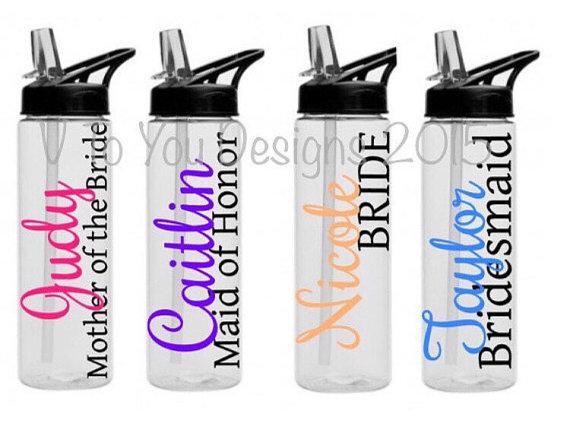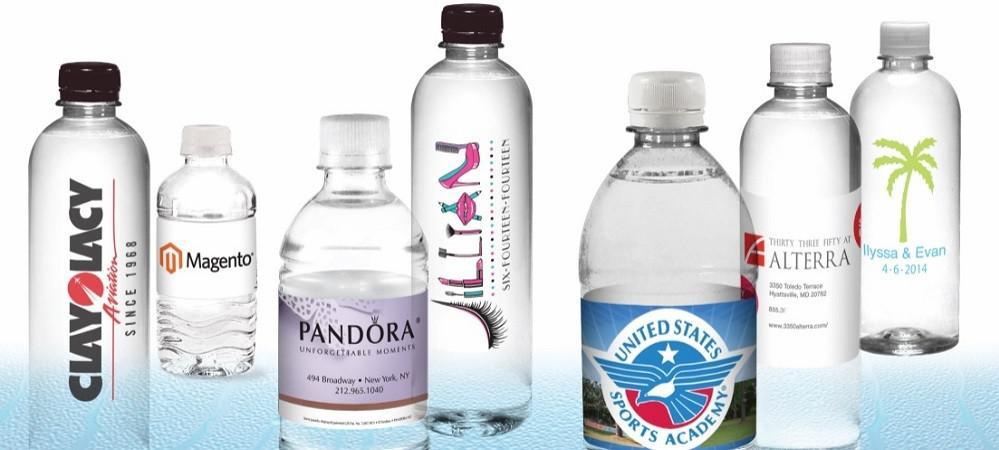The first image is the image on the left, the second image is the image on the right. Examine the images to the left and right. Is the description "There are two more bottles in one of the images than in the other." accurate? Answer yes or no. No. 